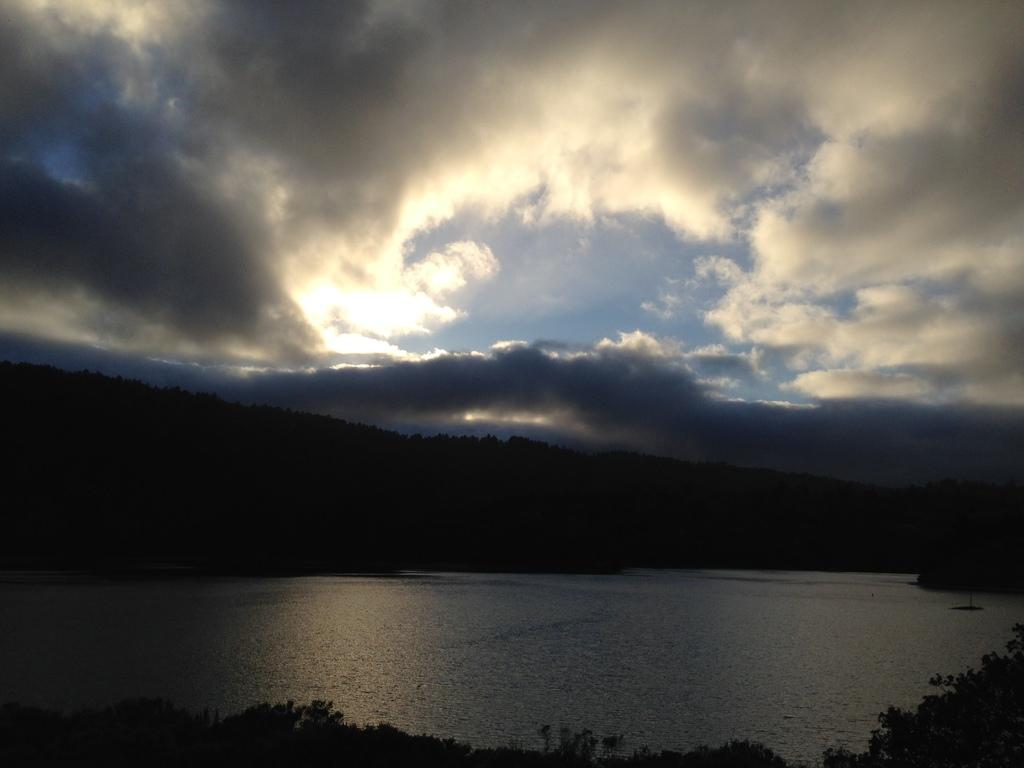What body of water is visible in the image? There is a lake in the image. What type of vegetation can be seen in the background of the image? There are trees in the background of the image. What is the condition of the sky in the background of the image? The sky is cloudy in the background of the image. What type of wood is being used by the servant in the image? There is no servant or wood present in the image. What type of blade is being used by the person in the image? There is no person or blade present in the image. 